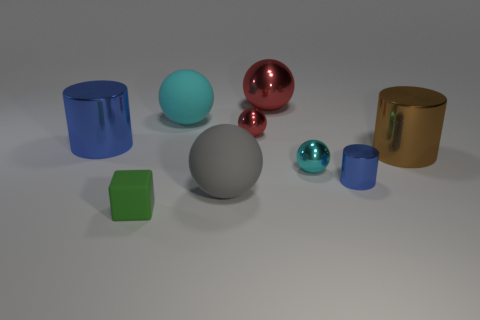Are there fewer cubes that are on the right side of the small blue metallic cylinder than green things? Yes, there are fewer cubes on the right side of the small blue metallic cylinder than the total number of green objects present. Specifically, there is one green cube and one green small sphere, making the total count of green objects two, while there is only one cube on the noted side. 